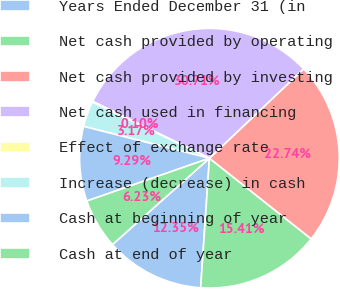Convert chart. <chart><loc_0><loc_0><loc_500><loc_500><pie_chart><fcel>Years Ended December 31 (in<fcel>Net cash provided by operating<fcel>Net cash provided by investing<fcel>Net cash used in financing<fcel>Effect of exchange rate<fcel>Increase (decrease) in cash<fcel>Cash at beginning of year<fcel>Cash at end of year<nl><fcel>12.35%<fcel>15.41%<fcel>22.74%<fcel>30.71%<fcel>0.1%<fcel>3.17%<fcel>9.29%<fcel>6.23%<nl></chart> 